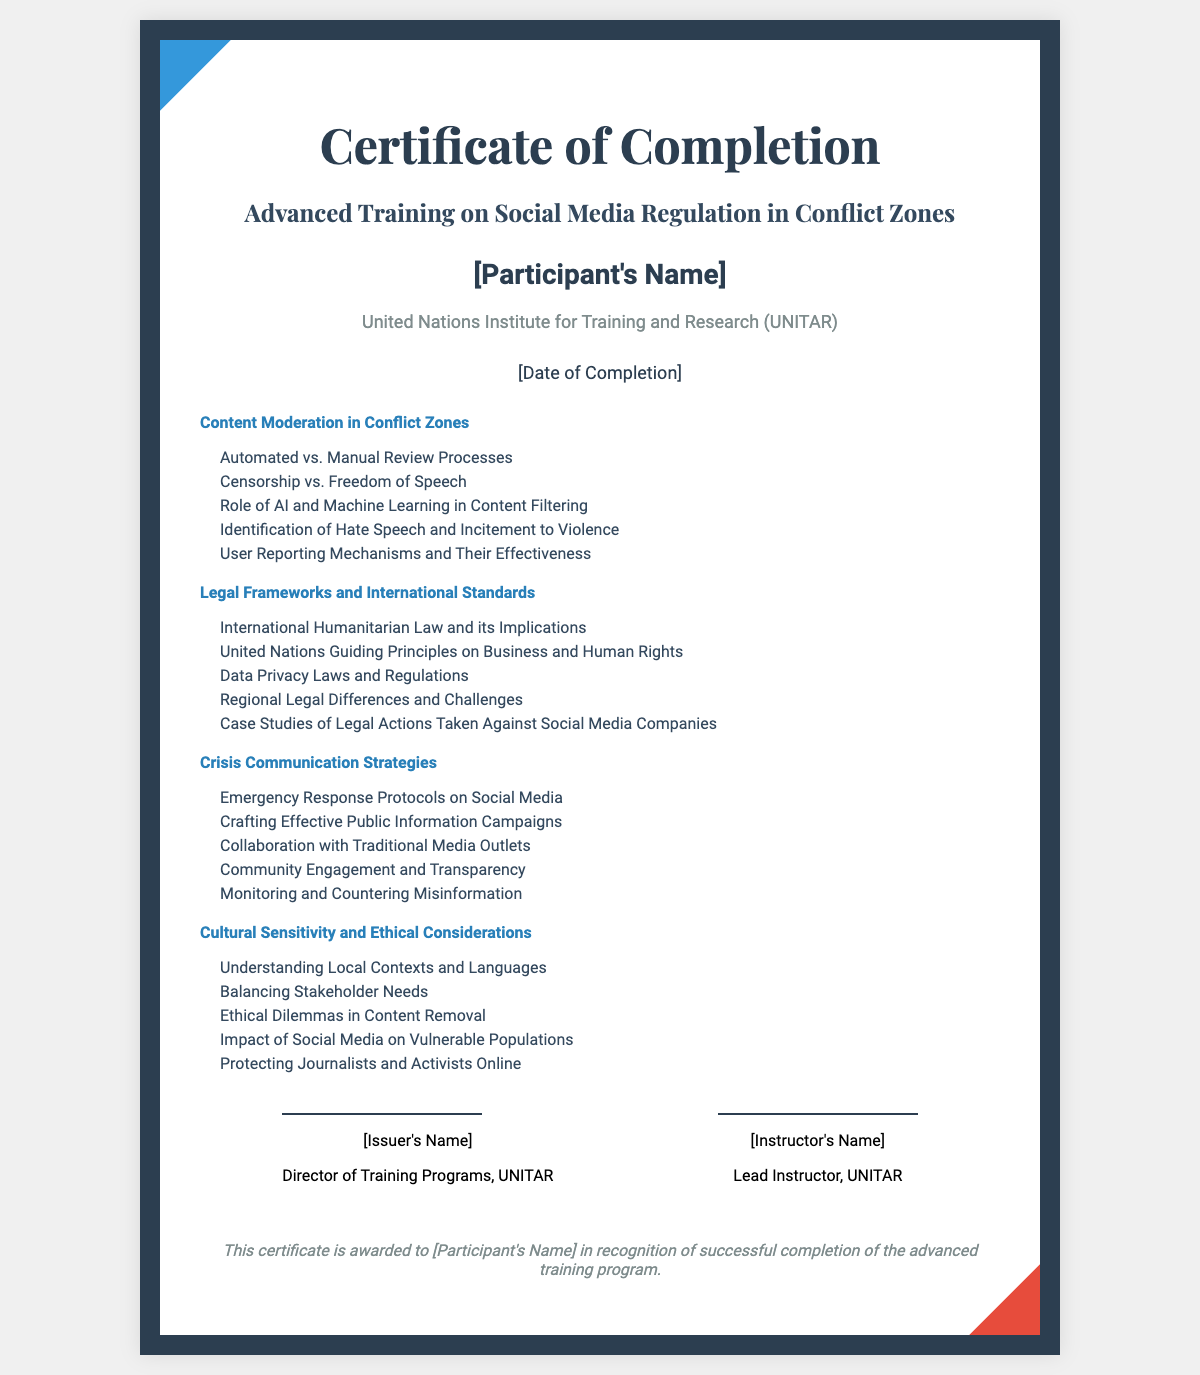What is the title of the training program? The title of the training program is specified in the document as "Advanced Training on Social Media Regulation in Conflict Zones."
Answer: Advanced Training on Social Media Regulation in Conflict Zones Who is the issuing organization? The issuing organization is mentioned in the document as the United Nations Institute for Training and Research.
Answer: United Nations Institute for Training and Research How many modules are covered in the training? The document lists four specific modules that are covered in the training program.
Answer: Four What is one key topic under Content Moderation? One key topic listed under Content Moderation is "Identification of Hate Speech and Incitement to Violence."
Answer: Identification of Hate Speech and Incitement to Violence What is the completion date placeholder in the document? The completion date is shown in the document as a placeholder represented by "[Date of Completion]."
Answer: [Date of Completion] Who signed the certificate as the Director of Training Programs? The document includes a placeholder for the name of the individual who signed as the Director of Training Programs.
Answer: [Issuer's Name] What is one ethical consideration mentioned in the modules? The document specifies that one ethical consideration is "Understanding Local Contexts and Languages."
Answer: Understanding Local Contexts and Languages Which module covers Emergency Response Protocols? The module that discusses Emergency Response Protocols is "Crisis Communication Strategies."
Answer: Crisis Communication Strategies How many key topics are listed under Legal Frameworks? Under the Legal Frameworks module, five key topics are listed as per the document.
Answer: Five 